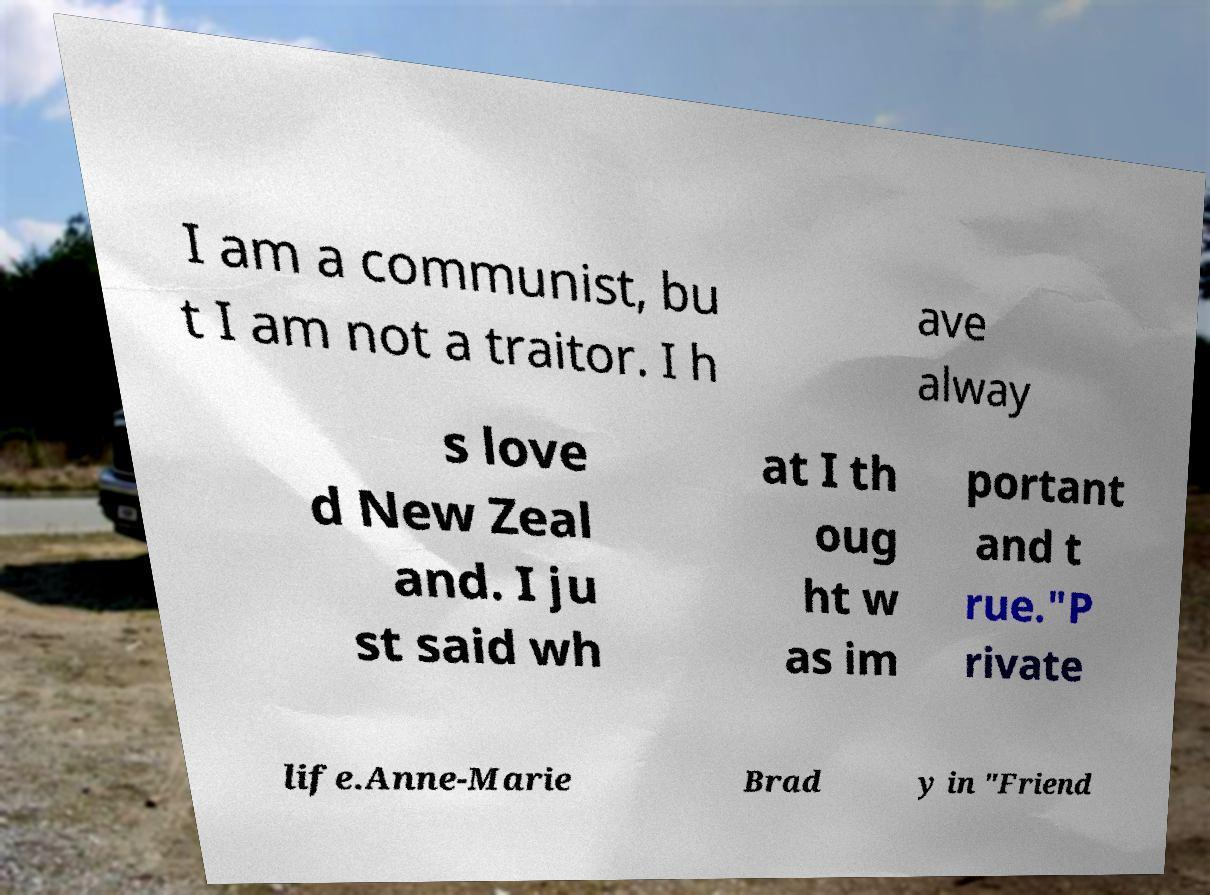Please read and relay the text visible in this image. What does it say? I am a communist, bu t I am not a traitor. I h ave alway s love d New Zeal and. I ju st said wh at I th oug ht w as im portant and t rue."P rivate life.Anne-Marie Brad y in "Friend 